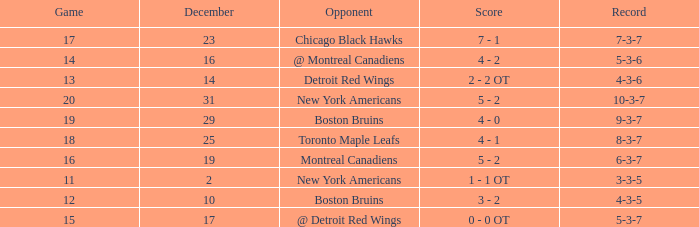Which December has a Record of 4-3-6? 14.0. 